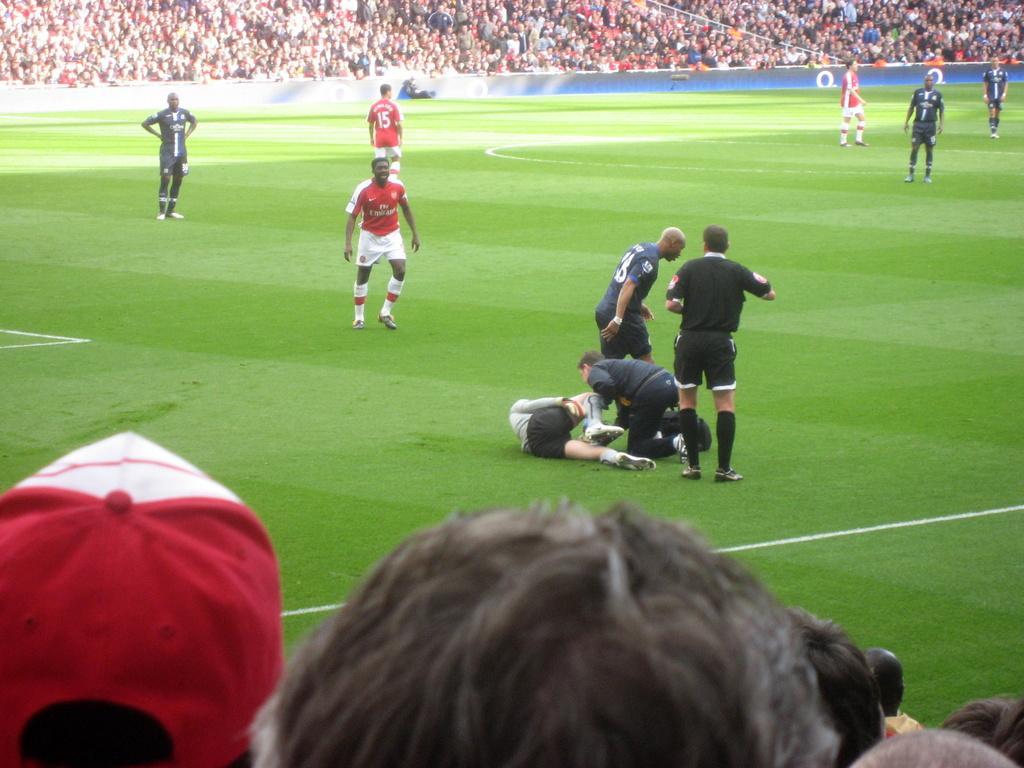Describe this image in one or two sentences. In this image I can see group of people playing game, in front the person is wearing black color dress and the person at left wearing red and white color dress. Background I can see a blue color board and I can see group of people sitting. 